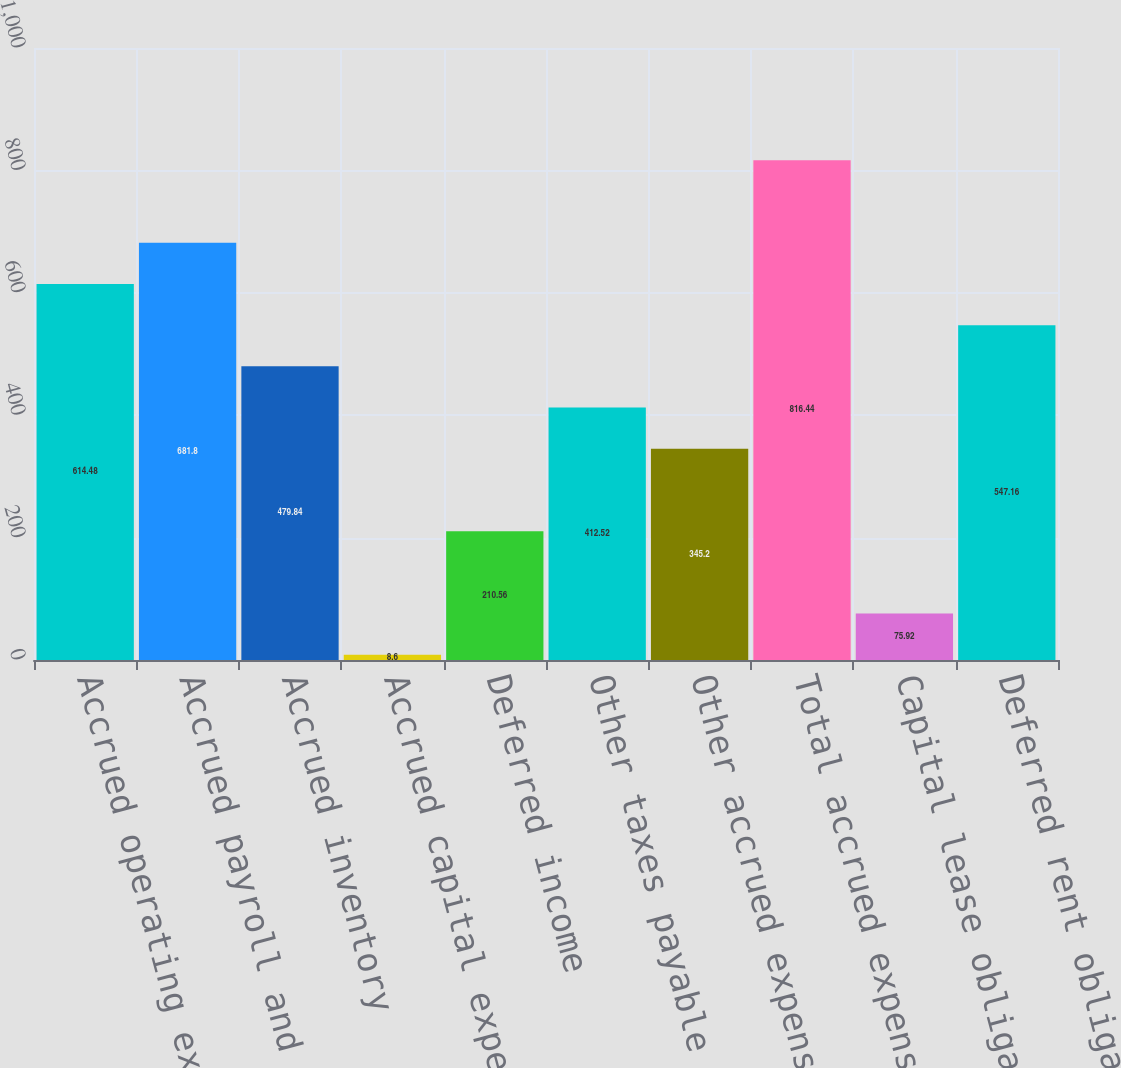<chart> <loc_0><loc_0><loc_500><loc_500><bar_chart><fcel>Accrued operating expenses<fcel>Accrued payroll and benefits<fcel>Accrued inventory<fcel>Accrued capital expenditures<fcel>Deferred income<fcel>Other taxes payable<fcel>Other accrued expenses and<fcel>Total accrued expenses and<fcel>Capital lease obligations<fcel>Deferred rent obligations<nl><fcel>614.48<fcel>681.8<fcel>479.84<fcel>8.6<fcel>210.56<fcel>412.52<fcel>345.2<fcel>816.44<fcel>75.92<fcel>547.16<nl></chart> 